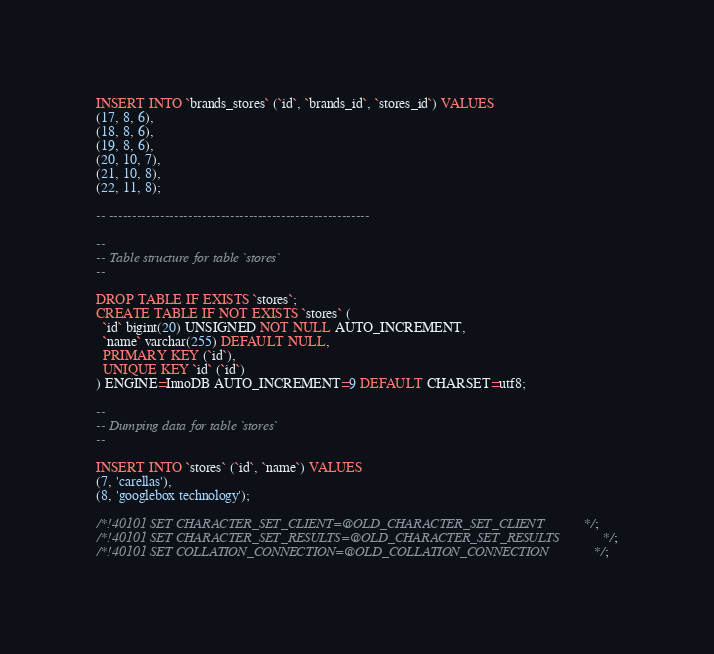Convert code to text. <code><loc_0><loc_0><loc_500><loc_500><_SQL_>INSERT INTO `brands_stores` (`id`, `brands_id`, `stores_id`) VALUES
(17, 8, 6),
(18, 8, 6),
(19, 8, 6),
(20, 10, 7),
(21, 10, 8),
(22, 11, 8);

-- --------------------------------------------------------

--
-- Table structure for table `stores`
--

DROP TABLE IF EXISTS `stores`;
CREATE TABLE IF NOT EXISTS `stores` (
  `id` bigint(20) UNSIGNED NOT NULL AUTO_INCREMENT,
  `name` varchar(255) DEFAULT NULL,
  PRIMARY KEY (`id`),
  UNIQUE KEY `id` (`id`)
) ENGINE=InnoDB AUTO_INCREMENT=9 DEFAULT CHARSET=utf8;

--
-- Dumping data for table `stores`
--

INSERT INTO `stores` (`id`, `name`) VALUES
(7, 'carellas'),
(8, 'googlebox technology');

/*!40101 SET CHARACTER_SET_CLIENT=@OLD_CHARACTER_SET_CLIENT */;
/*!40101 SET CHARACTER_SET_RESULTS=@OLD_CHARACTER_SET_RESULTS */;
/*!40101 SET COLLATION_CONNECTION=@OLD_COLLATION_CONNECTION */;
</code> 